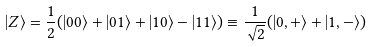Convert formula to latex. <formula><loc_0><loc_0><loc_500><loc_500>| Z \rangle = \frac { 1 } { 2 } ( | 0 0 \rangle + | 0 1 \rangle + | 1 0 \rangle - | 1 1 \rangle ) \equiv \frac { 1 } { \sqrt { 2 } } ( | 0 , + \rangle + | 1 , - \rangle )</formula> 